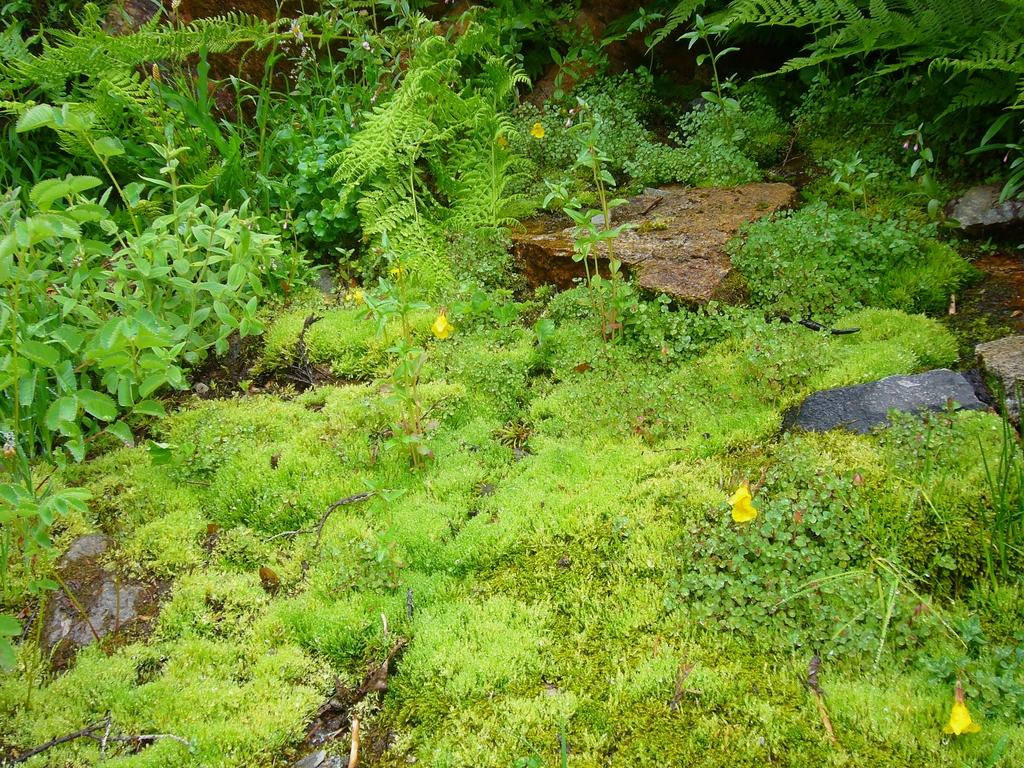What type of surface is visible in the image? There is grass on the surface in the image. What other natural elements can be seen in the image? There are plants and rocks in the image. How many matches are visible in the image? There are no matches present in the image. What type of heat source can be seen in the image? There is no heat source visible in the image. 